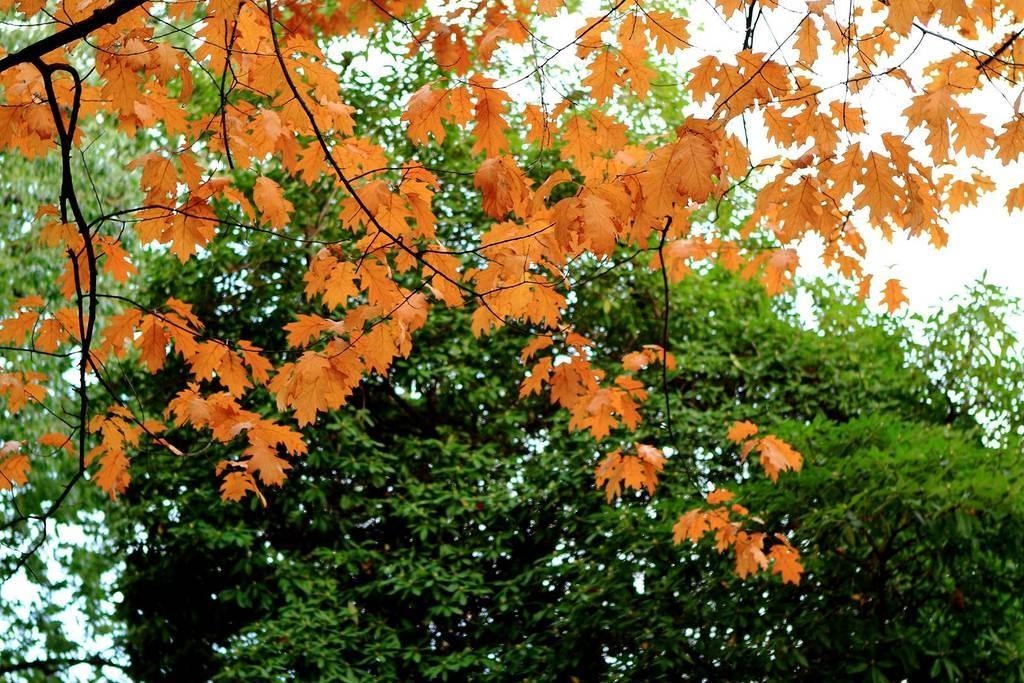What type of vegetation can be seen in the picture? There are trees in the picture. What color are the leaves on the trees? The leaves on the trees are orange. What is the condition of the sky in the picture? The sky is clear in the picture. What type of cable can be seen hanging from the trees in the image? There is no cable present in the image; it only features trees with orange leaves and a clear sky. What substance is being used to paint the leaves on the trees in the image? The image is a photograph, not a painting, and there is no indication of any substance being used to paint the leaves. 